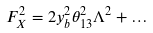Convert formula to latex. <formula><loc_0><loc_0><loc_500><loc_500>F _ { X } ^ { 2 } & = 2 y _ { b } ^ { 2 } \theta _ { 1 3 } ^ { 2 } \Lambda ^ { 2 } + \dots</formula> 